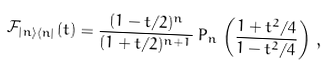Convert formula to latex. <formula><loc_0><loc_0><loc_500><loc_500>\mathcal { F } _ { | n \rangle \langle n | } ( t ) = \frac { ( 1 - t / 2 ) ^ { n } } { ( 1 + t / 2 ) ^ { n + 1 } } \, P _ { n } \, \left ( \frac { 1 + t ^ { 2 } / 4 } { 1 - t ^ { 2 } / 4 } \right ) \, ,</formula> 